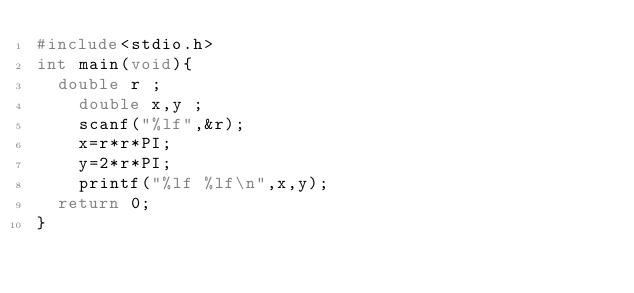Convert code to text. <code><loc_0><loc_0><loc_500><loc_500><_C_>#include<stdio.h>
int main(void){
	double r ;
    double x,y ;
    scanf("%lf",&r);
    x=r*r*PI;
    y=2*r*PI;
    printf("%lf %lf\n",x,y);
	return 0;
}</code> 